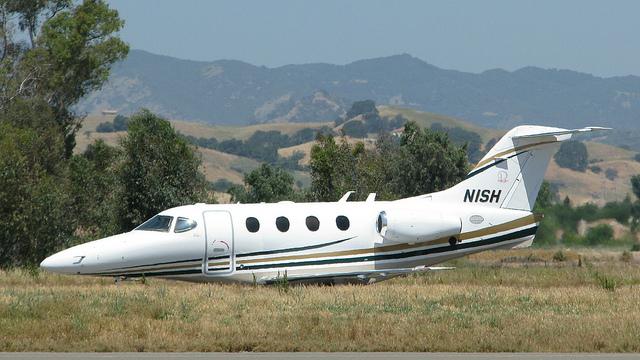What word is on the plane's tail?
Write a very short answer. Nish. How many windows are visible?
Quick response, please. 6. Did the plane crash?
Quick response, please. No. 